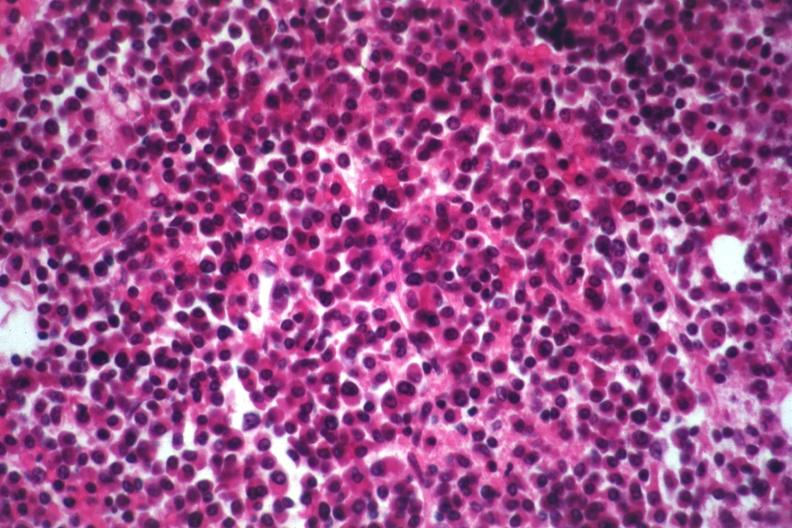s bone marrow present?
Answer the question using a single word or phrase. Yes 